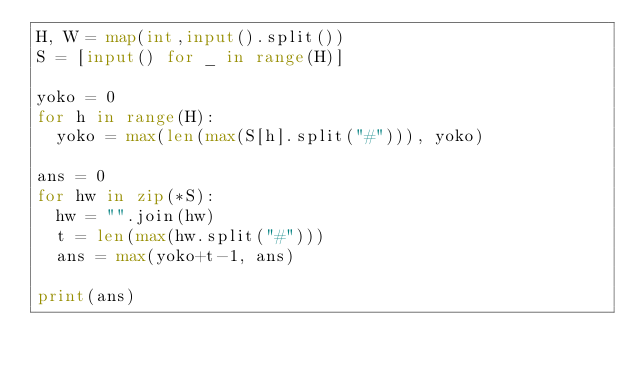<code> <loc_0><loc_0><loc_500><loc_500><_Python_>H, W = map(int,input().split())
S = [input() for _ in range(H)]

yoko = 0
for h in range(H):
  yoko = max(len(max(S[h].split("#"))), yoko)
  
ans = 0
for hw in zip(*S):
  hw = "".join(hw)
  t = len(max(hw.split("#")))
  ans = max(yoko+t-1, ans)
 
print(ans)</code> 